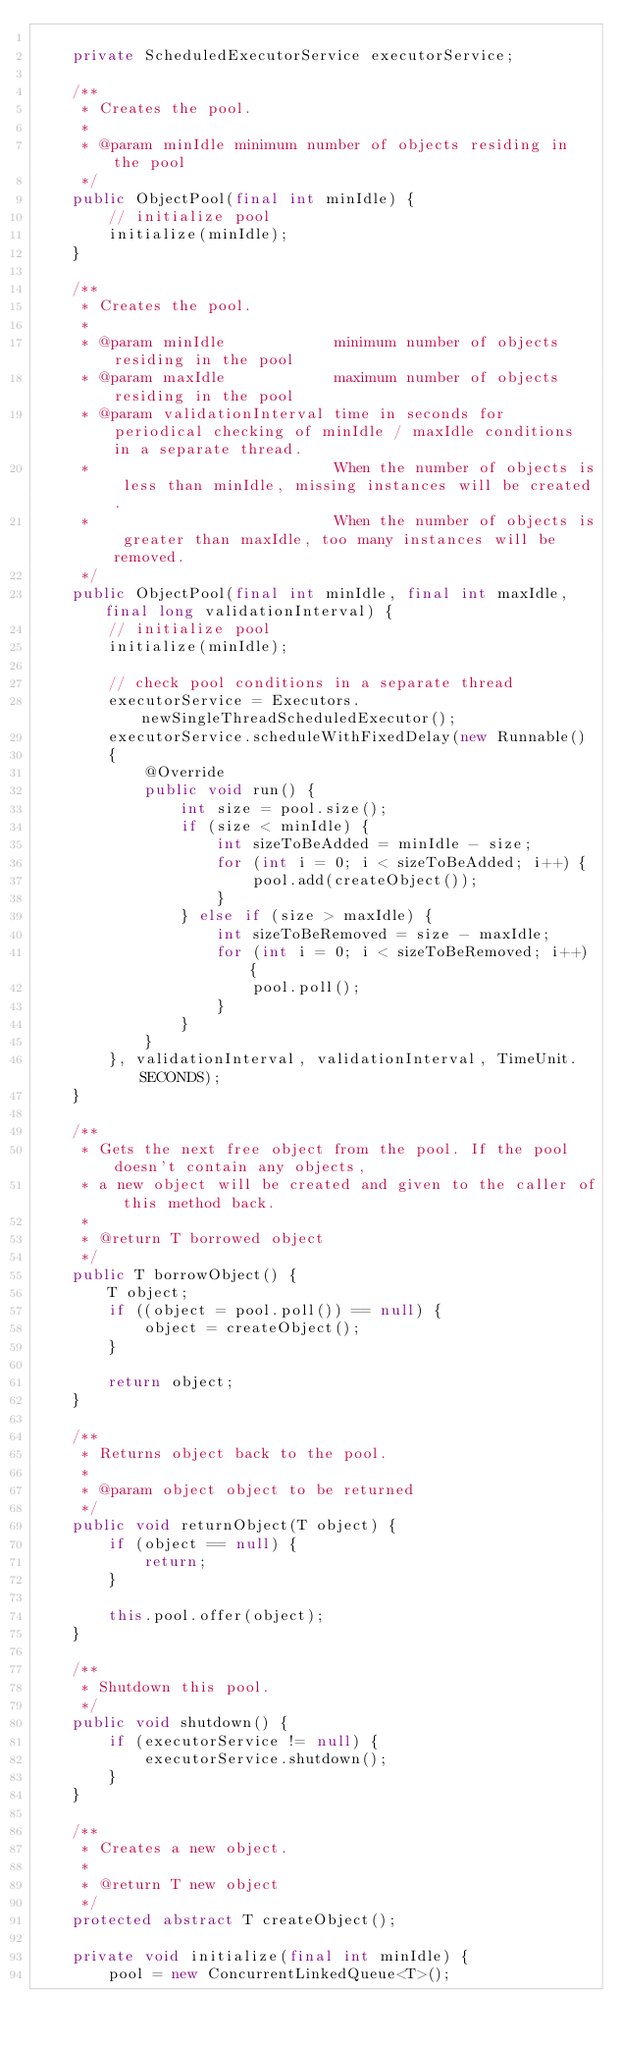<code> <loc_0><loc_0><loc_500><loc_500><_Java_>
    private ScheduledExecutorService executorService;

    /**
     * Creates the pool.
     *
     * @param minIdle minimum number of objects residing in the pool
     */
    public ObjectPool(final int minIdle) {
        // initialize pool
        initialize(minIdle);
    }

    /**
     * Creates the pool.
     *
     * @param minIdle            minimum number of objects residing in the pool
     * @param maxIdle            maximum number of objects residing in the pool
     * @param validationInterval time in seconds for periodical checking of minIdle / maxIdle conditions in a separate thread.
     *                           When the number of objects is less than minIdle, missing instances will be created.
     *                           When the number of objects is greater than maxIdle, too many instances will be removed.
     */
    public ObjectPool(final int minIdle, final int maxIdle, final long validationInterval) {
        // initialize pool
        initialize(minIdle);

        // check pool conditions in a separate thread
        executorService = Executors.newSingleThreadScheduledExecutor();
        executorService.scheduleWithFixedDelay(new Runnable()
        {
            @Override
            public void run() {
                int size = pool.size();
                if (size < minIdle) {
                    int sizeToBeAdded = minIdle - size;
                    for (int i = 0; i < sizeToBeAdded; i++) {
                        pool.add(createObject());
                    }
                } else if (size > maxIdle) {
                    int sizeToBeRemoved = size - maxIdle;
                    for (int i = 0; i < sizeToBeRemoved; i++) {
                        pool.poll();
                    }
                }
            }
        }, validationInterval, validationInterval, TimeUnit.SECONDS);
    }

    /**
     * Gets the next free object from the pool. If the pool doesn't contain any objects,
     * a new object will be created and given to the caller of this method back.
     *
     * @return T borrowed object
     */
    public T borrowObject() {
        T object;
        if ((object = pool.poll()) == null) {
            object = createObject();
        }

        return object;
    }

    /**
     * Returns object back to the pool.
     *
     * @param object object to be returned
     */
    public void returnObject(T object) {
        if (object == null) {
            return;
        }

        this.pool.offer(object);
    }

    /**
     * Shutdown this pool.
     */
    public void shutdown() {
        if (executorService != null) {
            executorService.shutdown();
        }
    }

    /**
     * Creates a new object.
     *
     * @return T new object
     */
    protected abstract T createObject();

    private void initialize(final int minIdle) {
        pool = new ConcurrentLinkedQueue<T>();
</code> 